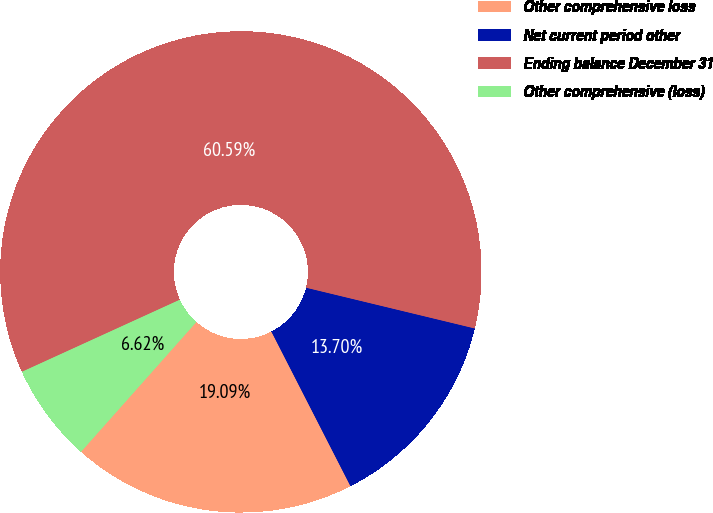Convert chart to OTSL. <chart><loc_0><loc_0><loc_500><loc_500><pie_chart><fcel>Other comprehensive loss<fcel>Net current period other<fcel>Ending balance December 31<fcel>Other comprehensive (loss)<nl><fcel>19.09%<fcel>13.7%<fcel>60.59%<fcel>6.62%<nl></chart> 